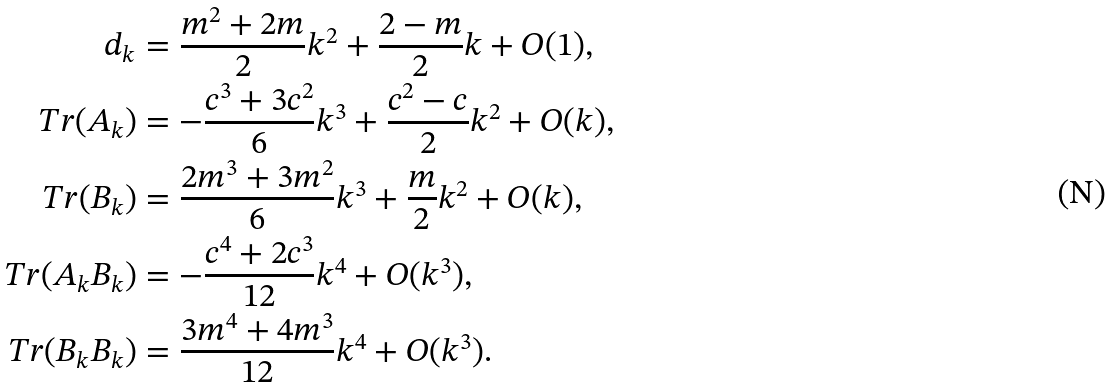<formula> <loc_0><loc_0><loc_500><loc_500>d _ { k } & = \frac { m ^ { 2 } + 2 m } { 2 } k ^ { 2 } + \frac { 2 - m } { 2 } k + O ( 1 ) , \\ T r ( A _ { k } ) & = - \frac { c ^ { 3 } + 3 c ^ { 2 } } { 6 } k ^ { 3 } + \frac { c ^ { 2 } - c } { 2 } k ^ { 2 } + O ( k ) , \\ T r ( B _ { k } ) & = \frac { 2 m ^ { 3 } + 3 m ^ { 2 } } { 6 } k ^ { 3 } + \frac { m } { 2 } k ^ { 2 } + O ( k ) , \\ T r ( A _ { k } B _ { k } ) & = - \frac { c ^ { 4 } + 2 c ^ { 3 } } { 1 2 } k ^ { 4 } + O ( k ^ { 3 } ) , \\ T r ( B _ { k } B _ { k } ) & = \frac { 3 m ^ { 4 } + 4 m ^ { 3 } } { 1 2 } k ^ { 4 } + O ( k ^ { 3 } ) .</formula> 